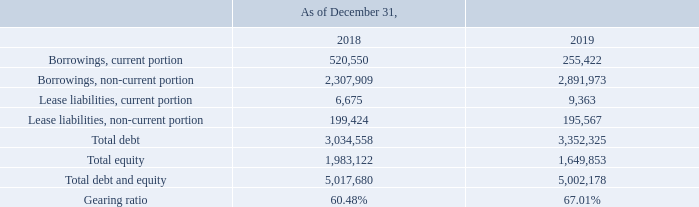GasLog Ltd. and its Subsidiaries
Notes to the consolidated financial statements (Continued)
For the years ended December 31, 2017, 2018 and 2019
(All amounts expressed in thousands of U.S. Dollars, except share and per share data)
25. Capital Risk Management
The Group’s objectives when managing capital are to safeguard the Group’s ability to continue as a going concern, to ensure that it maintains a strong credit rating and healthy capital ratios in order to support its business and maximize shareholders value.
The Group monitors capital using a gearing ratio, which is total debt divided by total equity plus total debt. The gearing ratio is calculated as follows:
How is gearing ratio calculated? Total debt divided by total equity plus total debt. What is the Group's goal when managing capital? To safeguard the group’s ability to continue as a going concern, to ensure that it maintains a strong credit rating and healthy capital ratios in order to support its business and maximize shareholders value. What are the components required to calculate gearing ratio? Total debt, total debt and equity. Which year has a higher Total equity? 1,983,122 > 1,649,853 
Answer: 2018. What was the change in gearing ratio from 2018 to 2019?
Answer scale should be: percent. 67.01% - 60.48% 
Answer: 6.53. What was the percentage change in total equity from 2018 to 2019?
Answer scale should be: percent. (1,649,853 - 1,983,122)/1,983,122 
Answer: -16.81. 